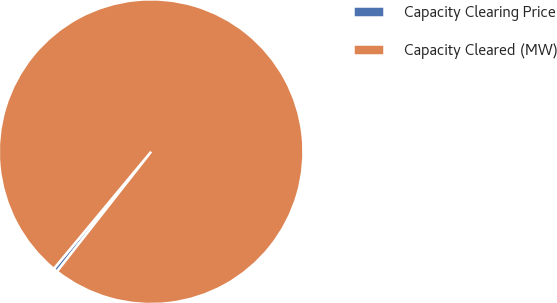Convert chart. <chart><loc_0><loc_0><loc_500><loc_500><pie_chart><fcel>Capacity Clearing Price<fcel>Capacity Cleared (MW)<nl><fcel>0.44%<fcel>99.56%<nl></chart> 